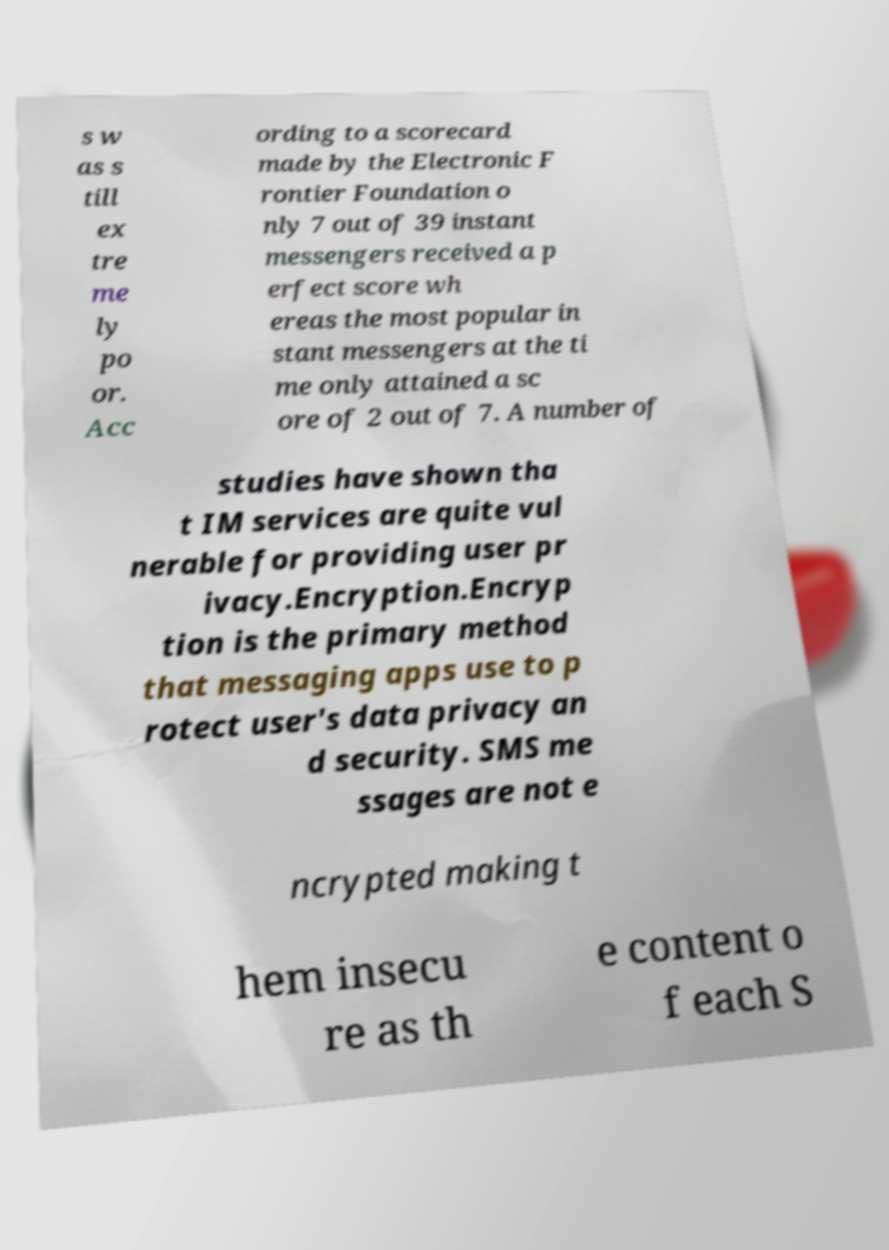Could you assist in decoding the text presented in this image and type it out clearly? s w as s till ex tre me ly po or. Acc ording to a scorecard made by the Electronic F rontier Foundation o nly 7 out of 39 instant messengers received a p erfect score wh ereas the most popular in stant messengers at the ti me only attained a sc ore of 2 out of 7. A number of studies have shown tha t IM services are quite vul nerable for providing user pr ivacy.Encryption.Encryp tion is the primary method that messaging apps use to p rotect user's data privacy an d security. SMS me ssages are not e ncrypted making t hem insecu re as th e content o f each S 